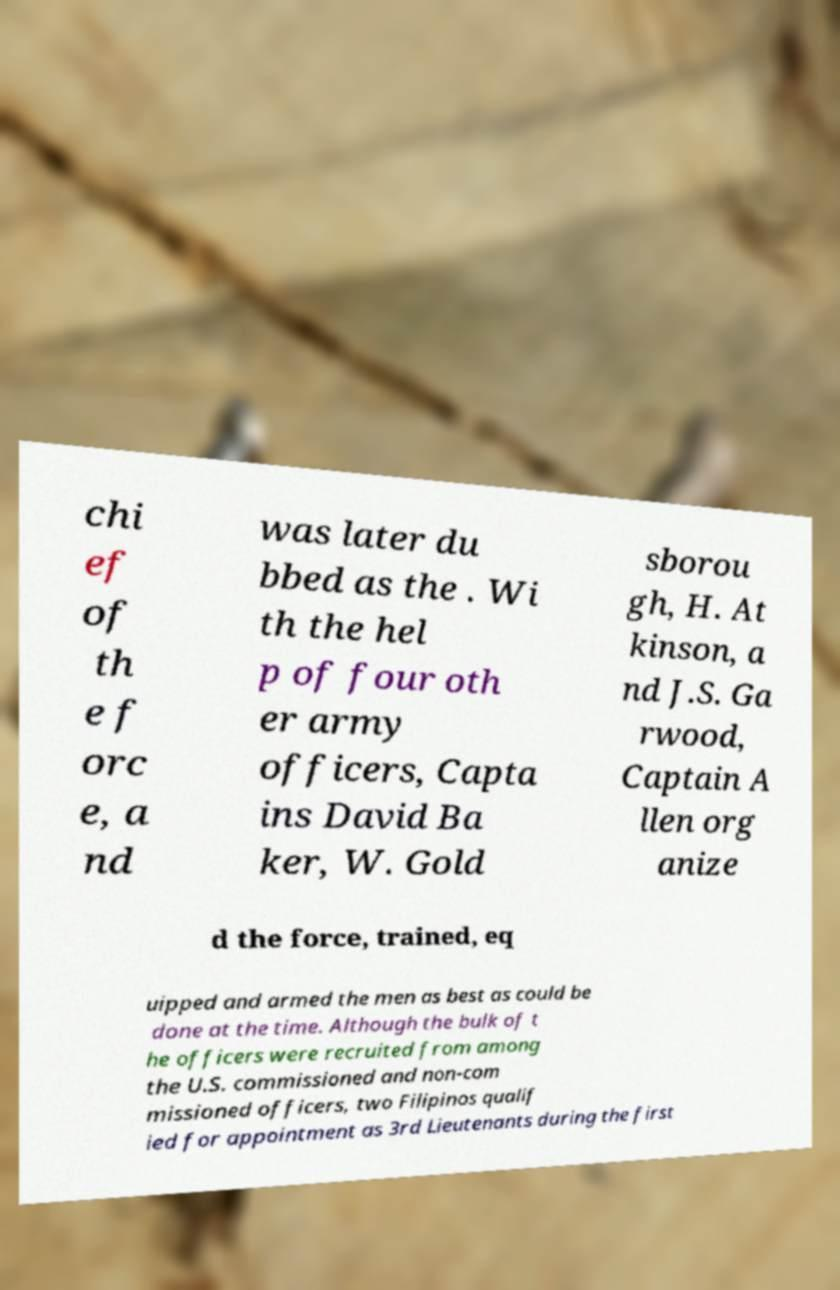What messages or text are displayed in this image? I need them in a readable, typed format. chi ef of th e f orc e, a nd was later du bbed as the . Wi th the hel p of four oth er army officers, Capta ins David Ba ker, W. Gold sborou gh, H. At kinson, a nd J.S. Ga rwood, Captain A llen org anize d the force, trained, eq uipped and armed the men as best as could be done at the time. Although the bulk of t he officers were recruited from among the U.S. commissioned and non-com missioned officers, two Filipinos qualif ied for appointment as 3rd Lieutenants during the first 